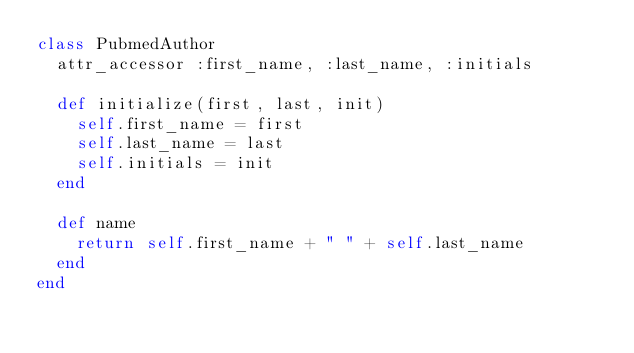Convert code to text. <code><loc_0><loc_0><loc_500><loc_500><_Ruby_>class PubmedAuthor
  attr_accessor :first_name, :last_name, :initials
  
  def initialize(first, last, init)
    self.first_name = first
    self.last_name = last
    self.initials = init    
  end
  
  def name
    return self.first_name + " " + self.last_name
  end
end</code> 